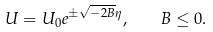Convert formula to latex. <formula><loc_0><loc_0><loc_500><loc_500>U = U _ { 0 } e ^ { \pm \sqrt { - 2 B } \eta } , \quad B \leq 0 .</formula> 